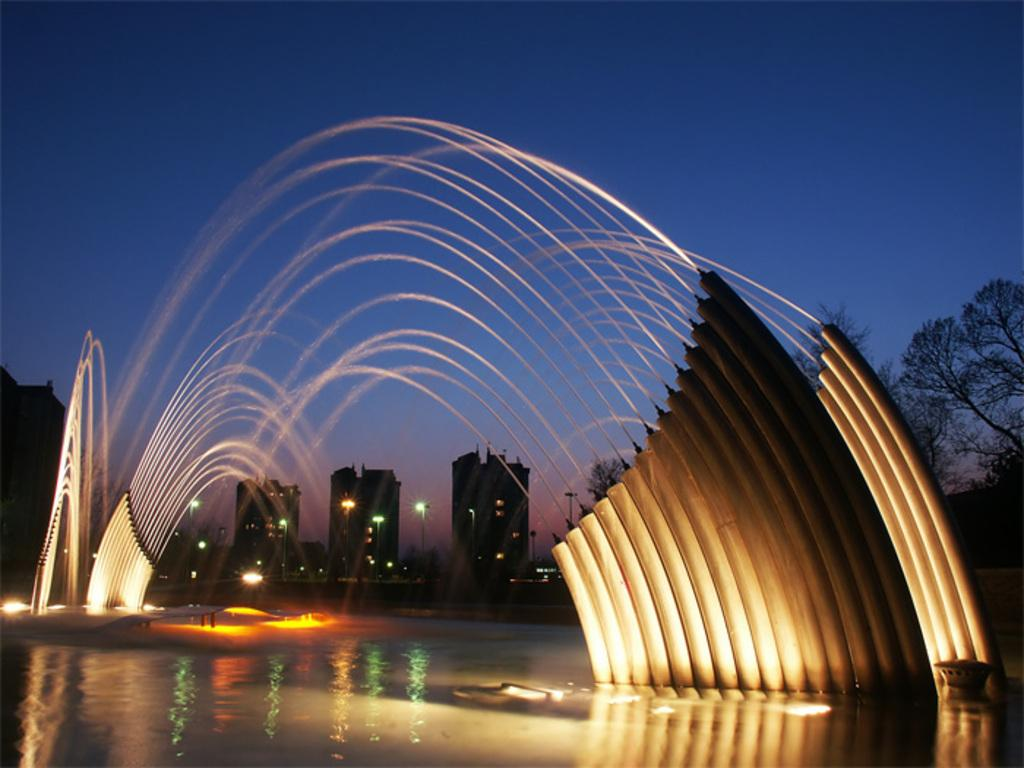What natural feature is present in the image? There is a waterfall in the image. What artificial features can be seen in the image? There are lights and buildings in the image. What is visible at the top of the image? The sky is visible at the top of the image. How many frogs are sitting on the crate in the image? There is no crate or frogs present in the image. What type of business is being conducted in the image? The image does not depict any business activities; it features a waterfall, lights, and buildings. 